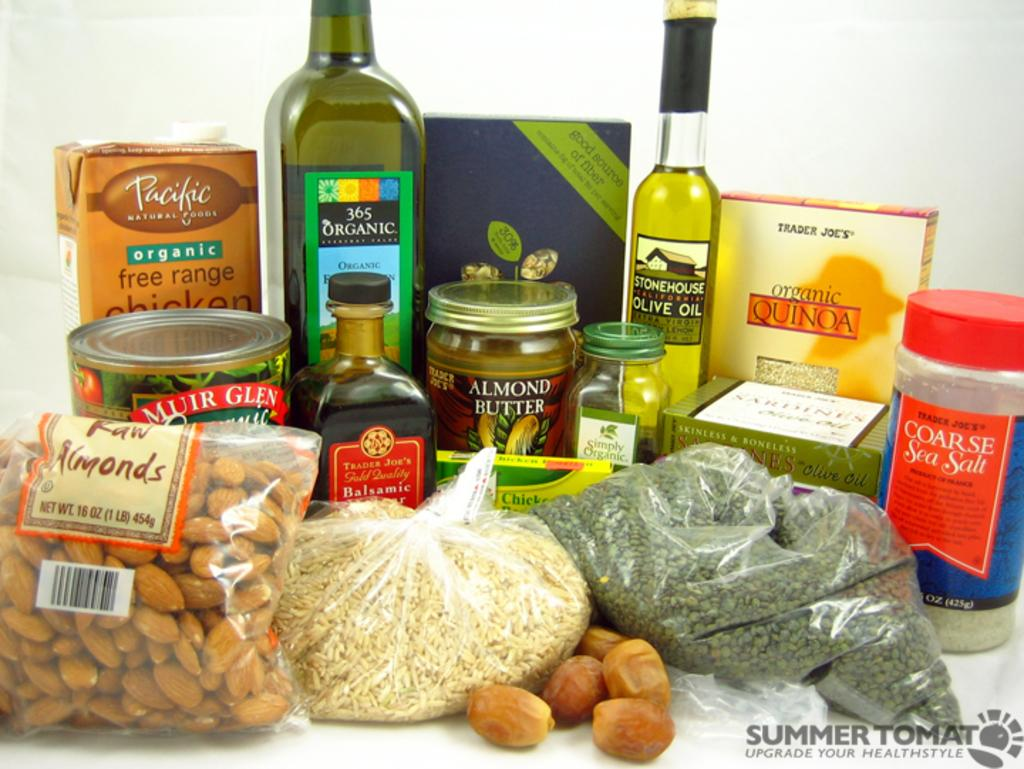<image>
Write a terse but informative summary of the picture. A group of several packaged foods including almonds, olive oil, almond butter, sea salt, and organic quinoa. 